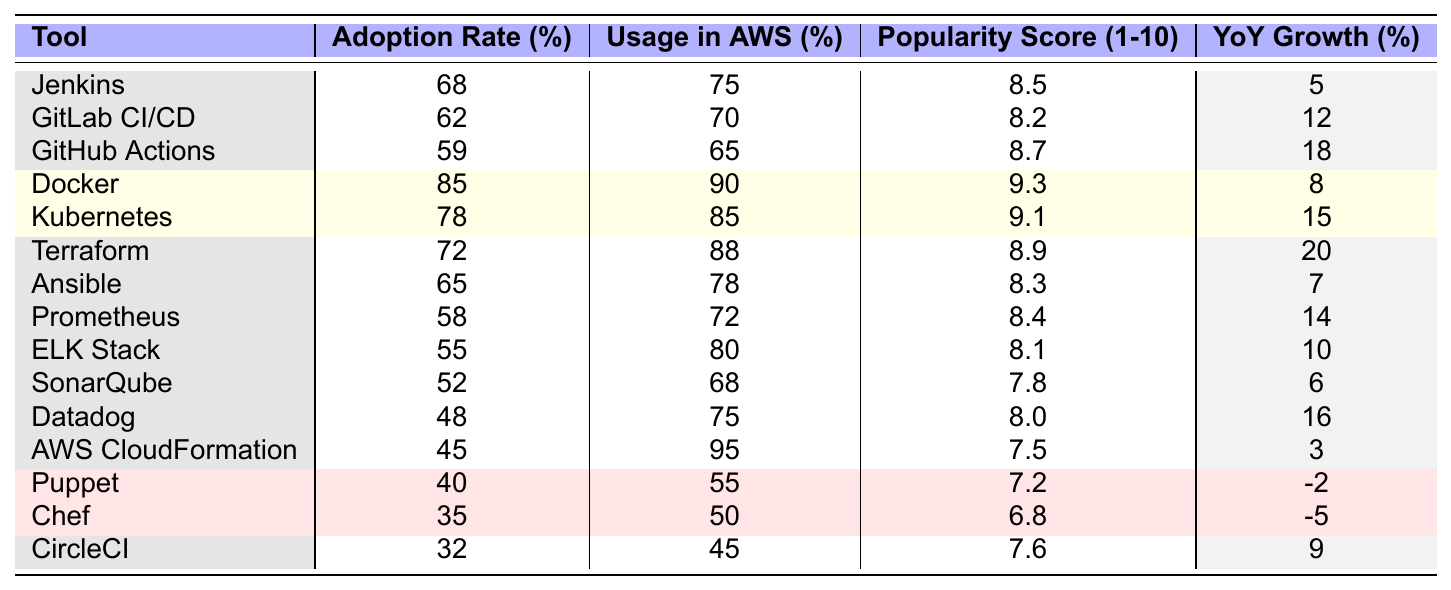What is the adoption rate of Docker? The table lists Docker's adoption rate directly under the "Adoption Rate (%)" column, which shows 85%.
Answer: 85% Which tool has the highest usage in AWS? By scanning the "Usage in AWS (%)" column in the table, we find that AWS CloudFormation has the highest usage at 95%.
Answer: AWS CloudFormation What is the popularity score of GitHub Actions? The popularity score is given in the "Popularity Score (1-10)" column, which indicates a score of 8.7 for GitHub Actions.
Answer: 8.7 What is the difference in adoption rates between Jenkins and CircleCI? Jenkins has an adoption rate of 68%, and CircleCI has an adoption rate of 32%. The difference is calculated as 68% - 32% = 36%.
Answer: 36% Are there any tools with a negative year-over-year growth? Looking at the "Year-over-Year Growth (%)" column, Puppet and Chef both show negative growth rates, at -2% and -5% respectively.
Answer: Yes Which tools have an adoption rate of over 60%? By checking the "Adoption Rate (%)" column, the tools that exceed 60% are Docker, Kubernetes, Terraform, Jenkins, GitLab CI/CD, and Ansible. This totals six tools.
Answer: 6 tools What is the average popularity score for tools with an adoption rate above 60%? The tools with adoption rates above 60% are Docker, Kubernetes, Terraform, Jenkins, GitLab CI/CD, and Ansible. Their popularity scores are 9.3, 9.1, 8.9, 8.5, 8.2, and 8.3. The sum is 52.3, and there are 6 tools, so the average is 52.3/6 = 8.7167.
Answer: 8.72 (approximately) Which tool had the highest year-over-year growth percentage? Examining the "Year-over-Year Growth (%)" column, Terraform shows the highest growth at 20%.
Answer: Terraform Is the usage in AWS for the ELK Stack greater than its popularity score? The "Usage in AWS (%)" for the ELK Stack is 80%, while the popularity score is 8.1 (or 81 when treated like a percentage). Since 80% is less than 81, the statement is false.
Answer: No What percentage of tools have an adoption rate below 50%? There are 15 tools total and 2 of them (Puppet and Chef) have an adoption rate below 50%. Therefore, the percentage is (2/15)*100 = 13.33%.
Answer: 13.33% 